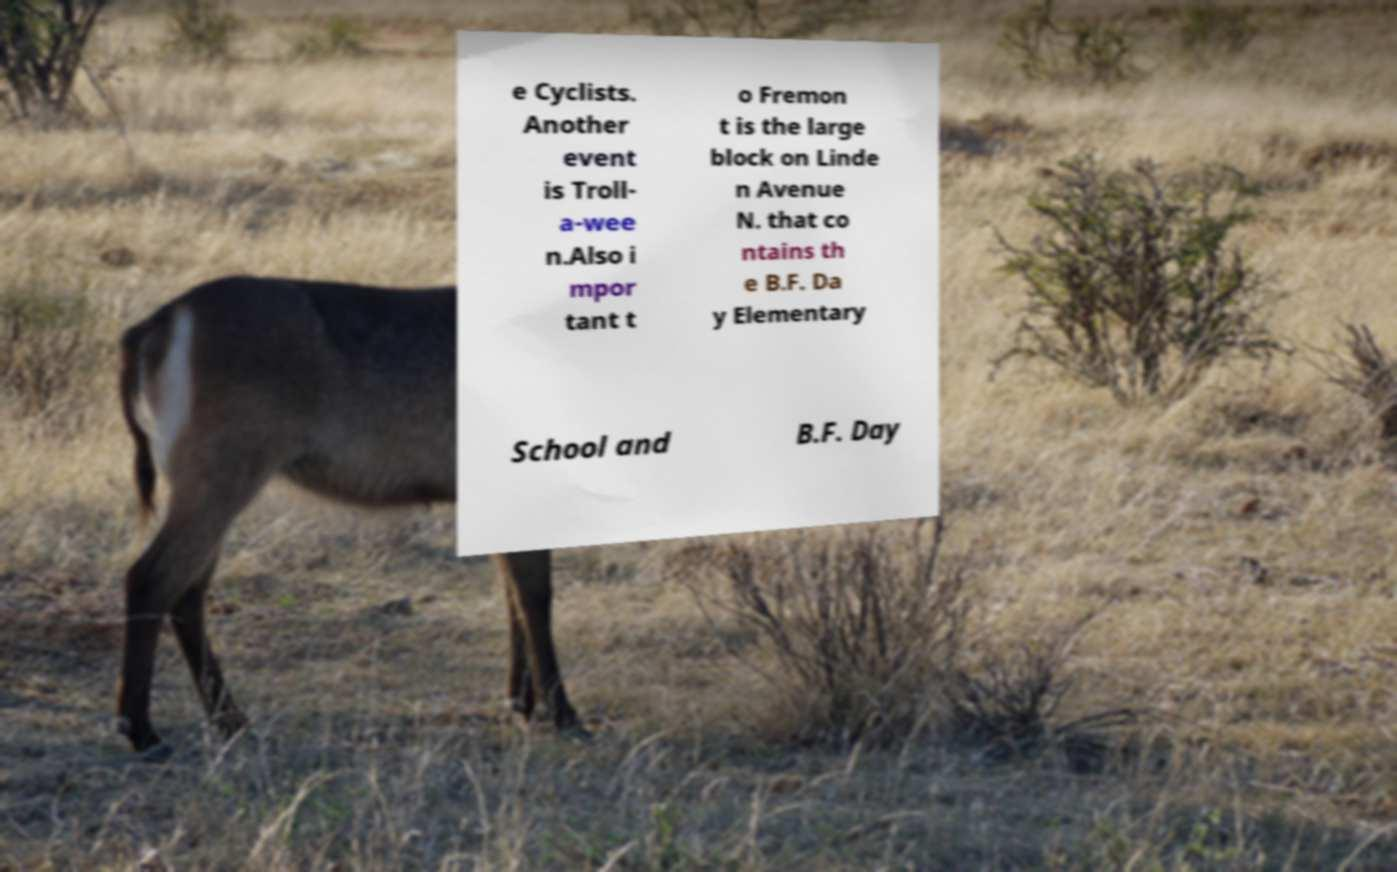There's text embedded in this image that I need extracted. Can you transcribe it verbatim? e Cyclists. Another event is Troll- a-wee n.Also i mpor tant t o Fremon t is the large block on Linde n Avenue N. that co ntains th e B.F. Da y Elementary School and B.F. Day 